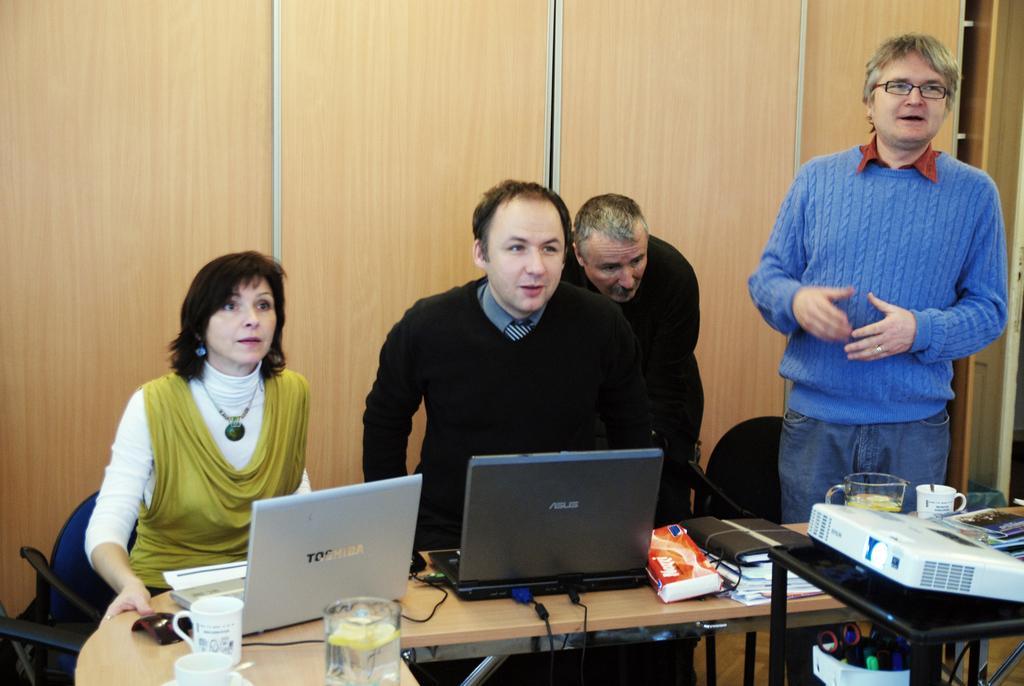How would you summarize this image in a sentence or two? In this picture there are four persons sitting and standing. At the right side the person wearing a blue colour dress is standing and speaking as his mouth is open. In the center on the table there are two laptops, diary, files, glass, cups. In the background there is door. Woman sitting on the chair is holding the table. 